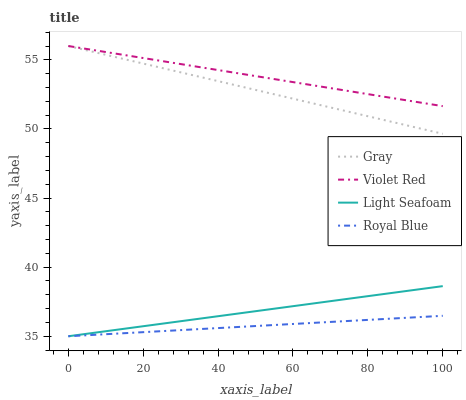Does Light Seafoam have the minimum area under the curve?
Answer yes or no. No. Does Light Seafoam have the maximum area under the curve?
Answer yes or no. No. Is Light Seafoam the smoothest?
Answer yes or no. No. Is Violet Red the roughest?
Answer yes or no. No. Does Violet Red have the lowest value?
Answer yes or no. No. Does Light Seafoam have the highest value?
Answer yes or no. No. Is Light Seafoam less than Gray?
Answer yes or no. Yes. Is Gray greater than Royal Blue?
Answer yes or no. Yes. Does Light Seafoam intersect Gray?
Answer yes or no. No. 